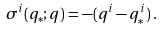Convert formula to latex. <formula><loc_0><loc_0><loc_500><loc_500>\sigma ^ { i } ( q _ { \ast } ; q ) = - ( q ^ { i } - q _ { \ast } ^ { i } ) \, .</formula> 